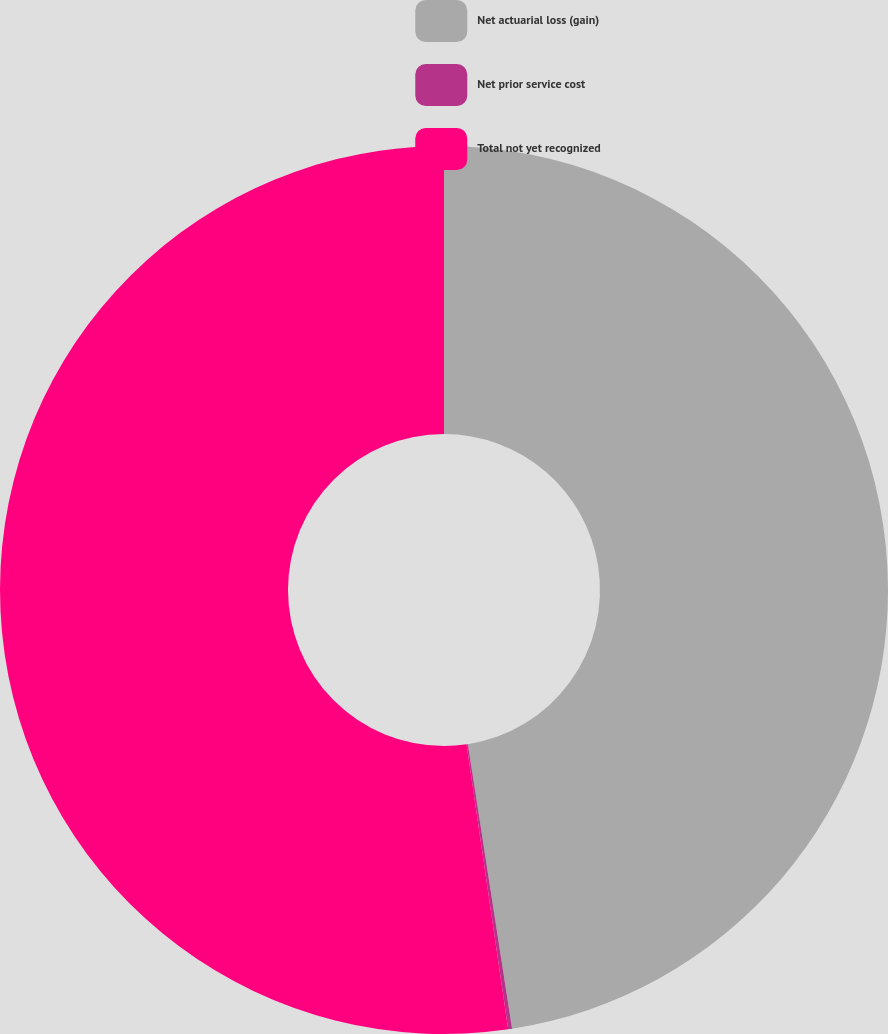<chart> <loc_0><loc_0><loc_500><loc_500><pie_chart><fcel>Net actuarial loss (gain)<fcel>Net prior service cost<fcel>Total not yet recognized<nl><fcel>47.55%<fcel>0.14%<fcel>52.31%<nl></chart> 